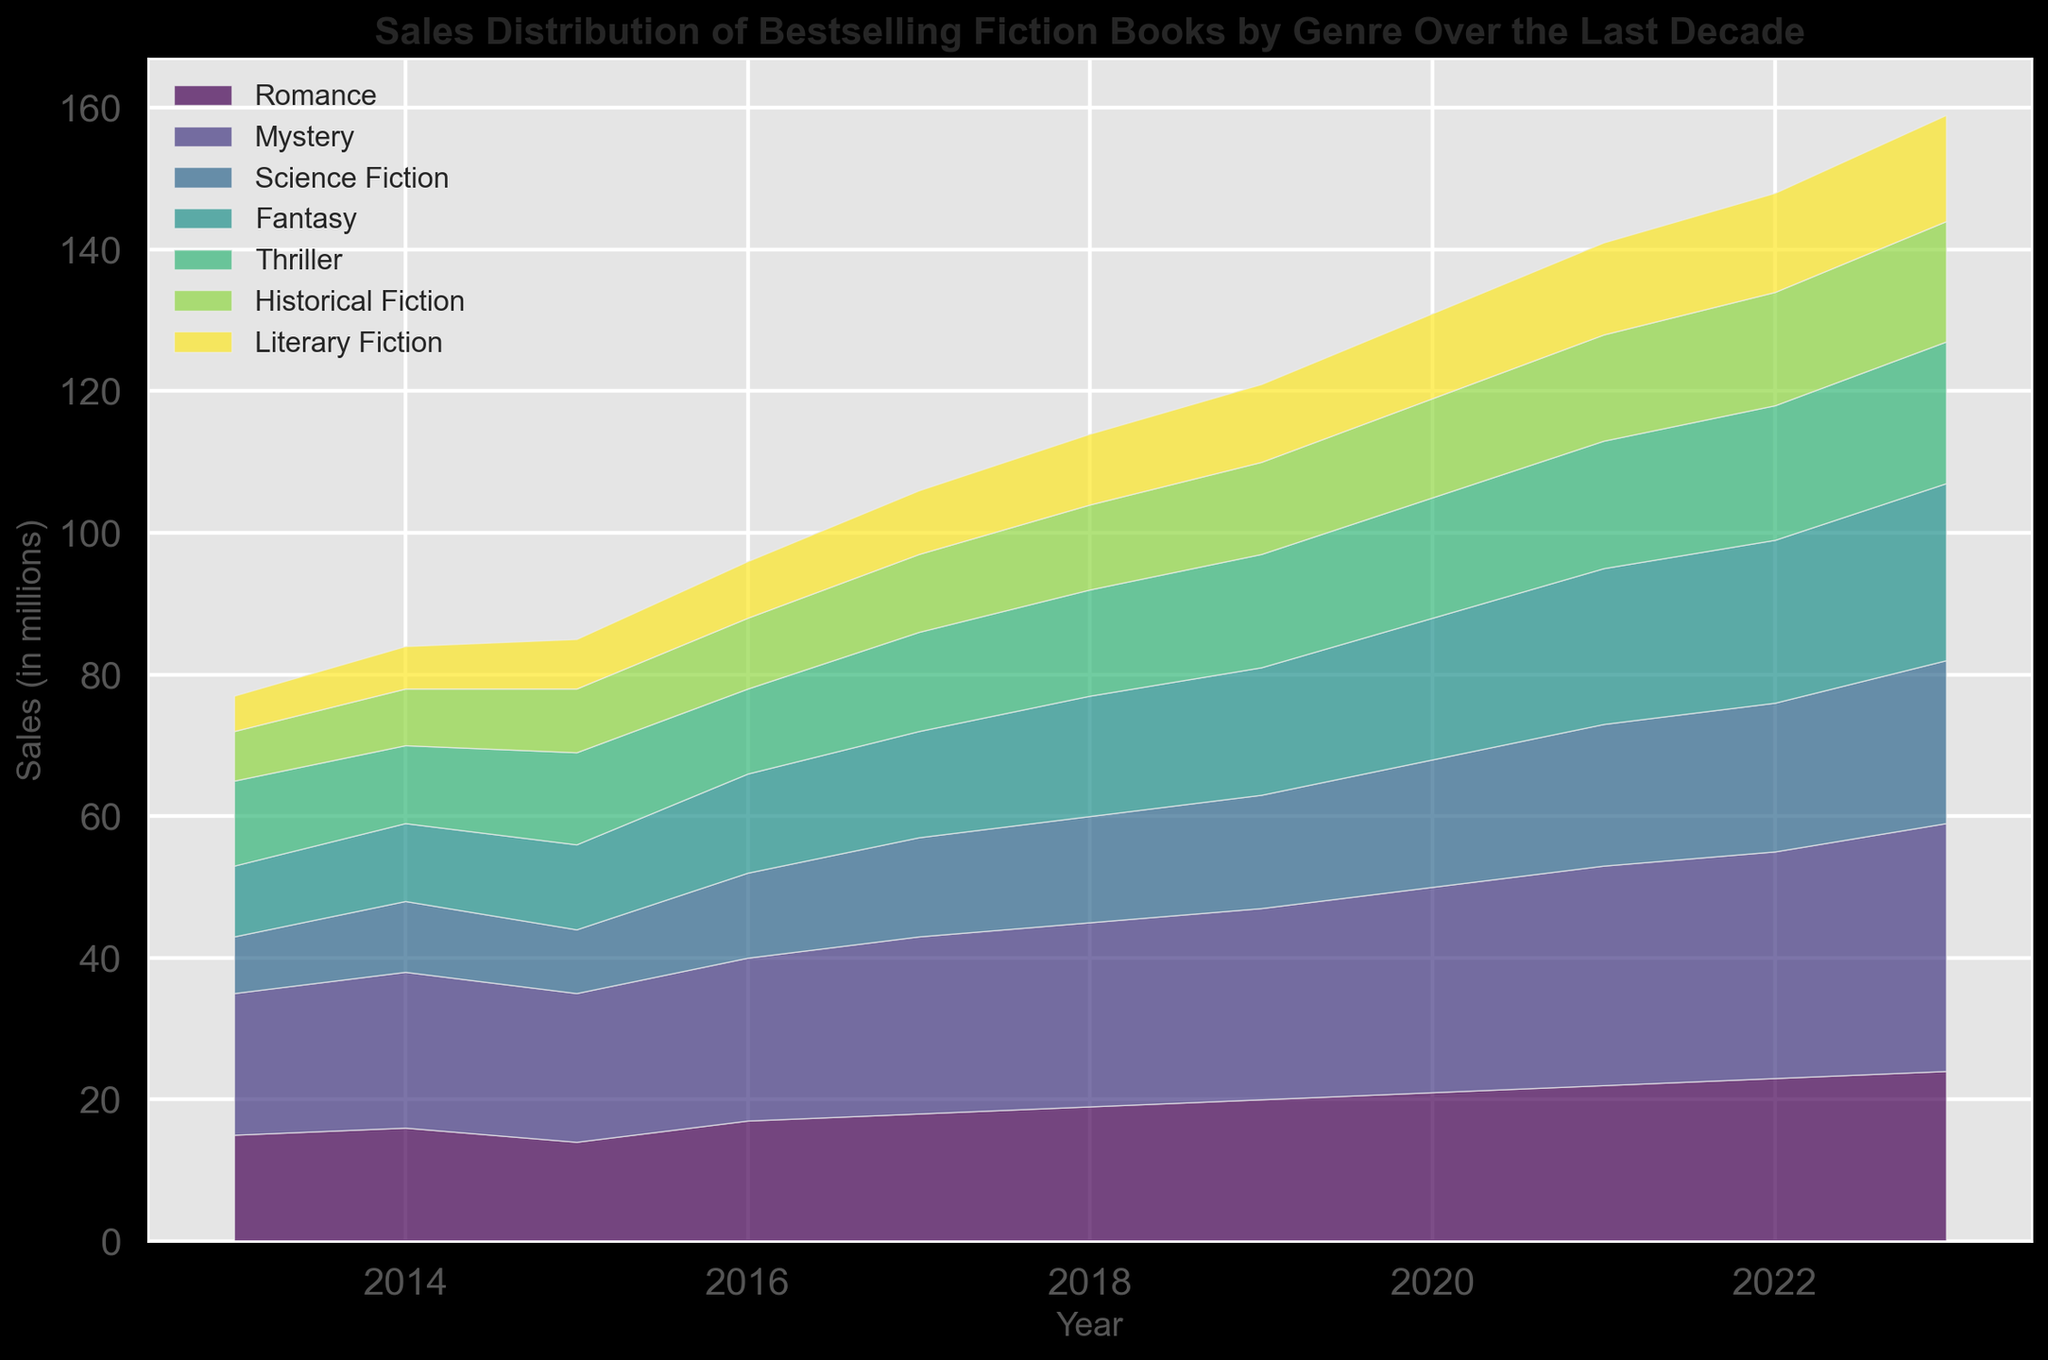What's the trend of sales in the Romance genre over the last decade? To find the trend, observe the Romance sales values from 2013 to 2023. The sales numbers increase from 15 in 2013 to 24 in 2023, indicating an upward trend.
Answer: Upward Which genre had the highest sales in 2023? By looking at the topmost segment of the stacked area chart for 2023, the largest segment corresponds to the Mystery genre with sales nearing 35 million.
Answer: Mystery Compare the sales in the Science Fiction and Fantasy genres in 2020. Which genre sold more? Observe the 2020 data points for Science Fiction and Fantasy. Science Fiction had sales of 18 million, while Fantasy had 20 million. Therefore, Fantasy sold more.
Answer: Fantasy What's the total sales across all genres in the year 2017? Add up the sales of all genres for 2017: Romance (18) + Mystery (25) + Science Fiction (14) + Fantasy (15) + Thriller (14) + Historical Fiction (11) + Literary Fiction (9) = 106 million.
Answer: 106 million How did the sales for Historical Fiction change from 2015 to 2018? Compare the sales figures for Historical Fiction in 2015 (9 million) and 2018 (12 million). There was an increase of 3 million.
Answer: Increase Identify the year in which Thriller genre sales surpassed 15 million for the first time. Identify the years in the chart and look for when the Thriller segment crossed the 15 million mark. In 2018, Thriller sales were exactly 15 million, and by 2019 they reached 16 million, surpassing 15 million for the first time.
Answer: 2019 Which genre showed the largest growth in sales from 2013 to 2023? Compare the difference in sales from 2013 to 2023 for each genre: Romance (9 million increase), Mystery (15 million increase), Science Fiction (15 million increase), Fantasy (15 million increase), Thriller (8 million increase), Historical Fiction (10 million increase), Literary Fiction (10 million increase). Three genres (Mystery, Science Fiction, and Fantasy) showed the largest growth of 15 million each.
Answer: Mystery, Science Fiction, Fantasy If you average the sales in the Romance genre over the decade, what is the value? Add up the sales in the Romance genre from 2013 to 2023 and divide by 11: (15 + 16 + 14 + 17 + 18 + 19 + 20 + 21 + 22 + 23 + 24) / 11 = 199 / 11 ≈ 18.09 million.
Answer: 18.09 million 